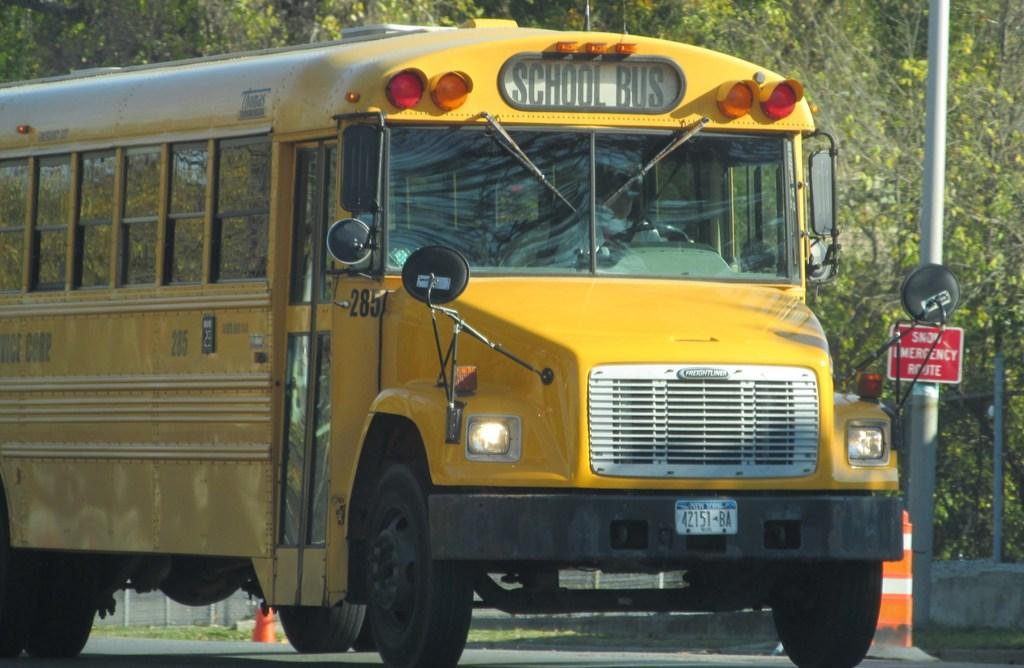Provide a one-sentence caption for the provided image. the front end of a yellow School Bus. 